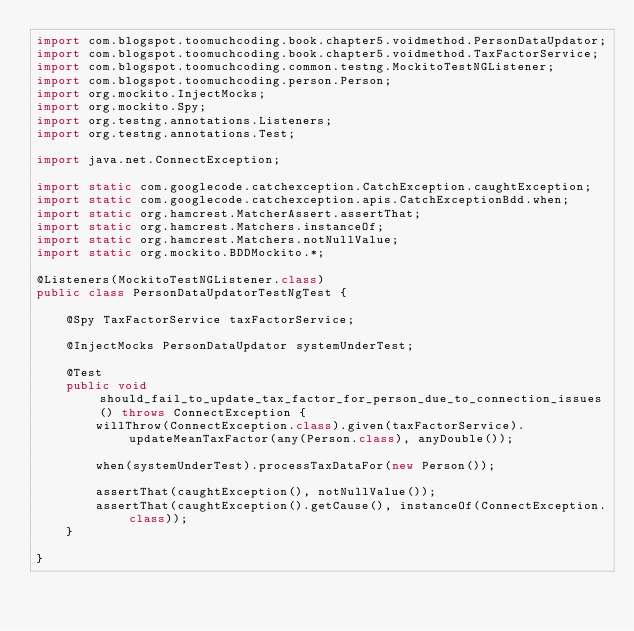Convert code to text. <code><loc_0><loc_0><loc_500><loc_500><_Java_>import com.blogspot.toomuchcoding.book.chapter5.voidmethod.PersonDataUpdator;
import com.blogspot.toomuchcoding.book.chapter5.voidmethod.TaxFactorService;
import com.blogspot.toomuchcoding.common.testng.MockitoTestNGListener;
import com.blogspot.toomuchcoding.person.Person;
import org.mockito.InjectMocks;
import org.mockito.Spy;
import org.testng.annotations.Listeners;
import org.testng.annotations.Test;

import java.net.ConnectException;

import static com.googlecode.catchexception.CatchException.caughtException;
import static com.googlecode.catchexception.apis.CatchExceptionBdd.when;
import static org.hamcrest.MatcherAssert.assertThat;
import static org.hamcrest.Matchers.instanceOf;
import static org.hamcrest.Matchers.notNullValue;
import static org.mockito.BDDMockito.*;

@Listeners(MockitoTestNGListener.class)
public class PersonDataUpdatorTestNgTest {

	@Spy TaxFactorService taxFactorService;

    @InjectMocks PersonDataUpdator systemUnderTest;

    @Test
    public void should_fail_to_update_tax_factor_for_person_due_to_connection_issues() throws ConnectException {        
        willThrow(ConnectException.class).given(taxFactorService).updateMeanTaxFactor(any(Person.class), anyDouble());

	    when(systemUnderTest).processTaxDataFor(new Person());

        assertThat(caughtException(), notNullValue());
        assertThat(caughtException().getCause(), instanceOf(ConnectException.class));
    }
	
}


</code> 